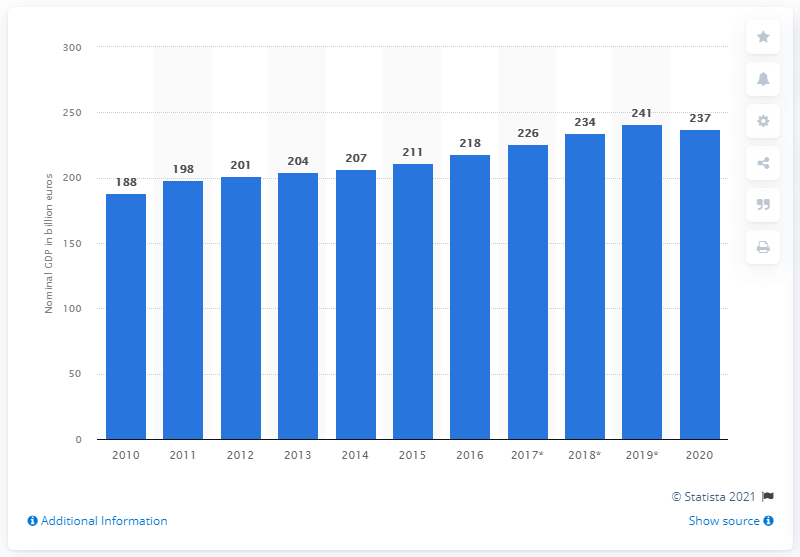Indicate a few pertinent items in this graphic. According to recent estimates, the Gross Domestic Product (GDP) of Finland in 2020 was approximately 237 billion dollars. 